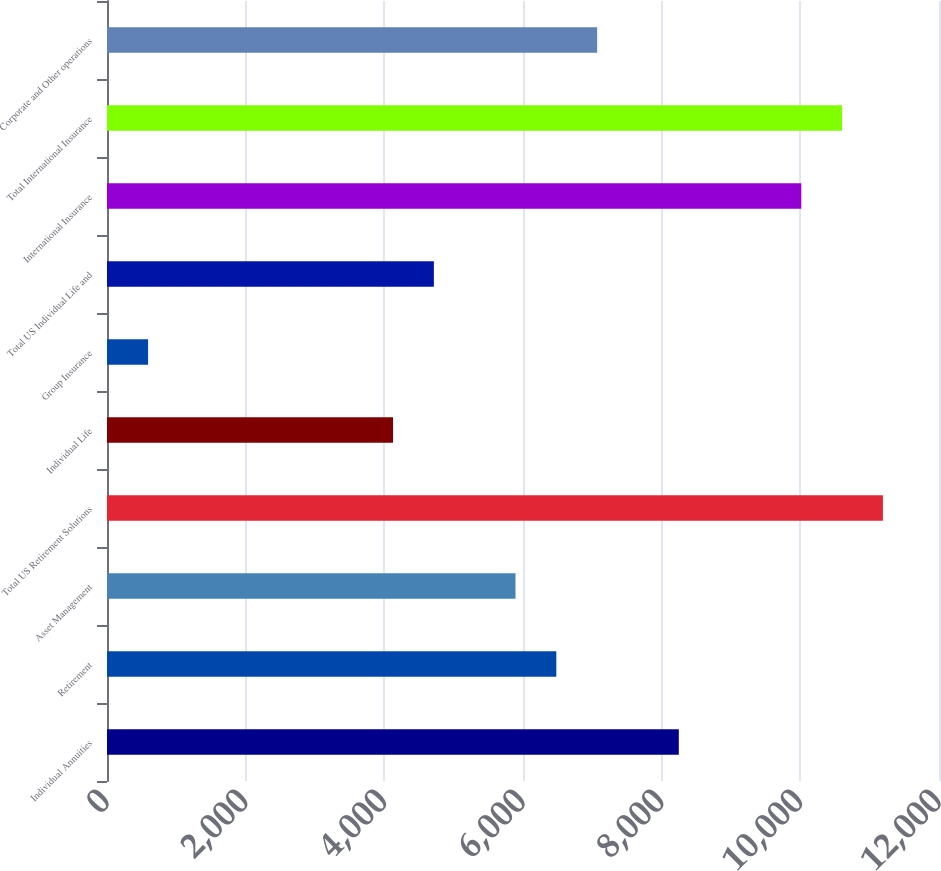Convert chart to OTSL. <chart><loc_0><loc_0><loc_500><loc_500><bar_chart><fcel>Individual Annuities<fcel>Retirement<fcel>Asset Management<fcel>Total US Retirement Solutions<fcel>Individual Life<fcel>Group Insurance<fcel>Total US Individual Life and<fcel>International Insurance<fcel>Total International Insurance<fcel>Corporate and Other operations<nl><fcel>8247.24<fcel>6480.78<fcel>5891.96<fcel>11191.3<fcel>4125.5<fcel>592.58<fcel>4714.32<fcel>10013.7<fcel>10602.5<fcel>7069.6<nl></chart> 